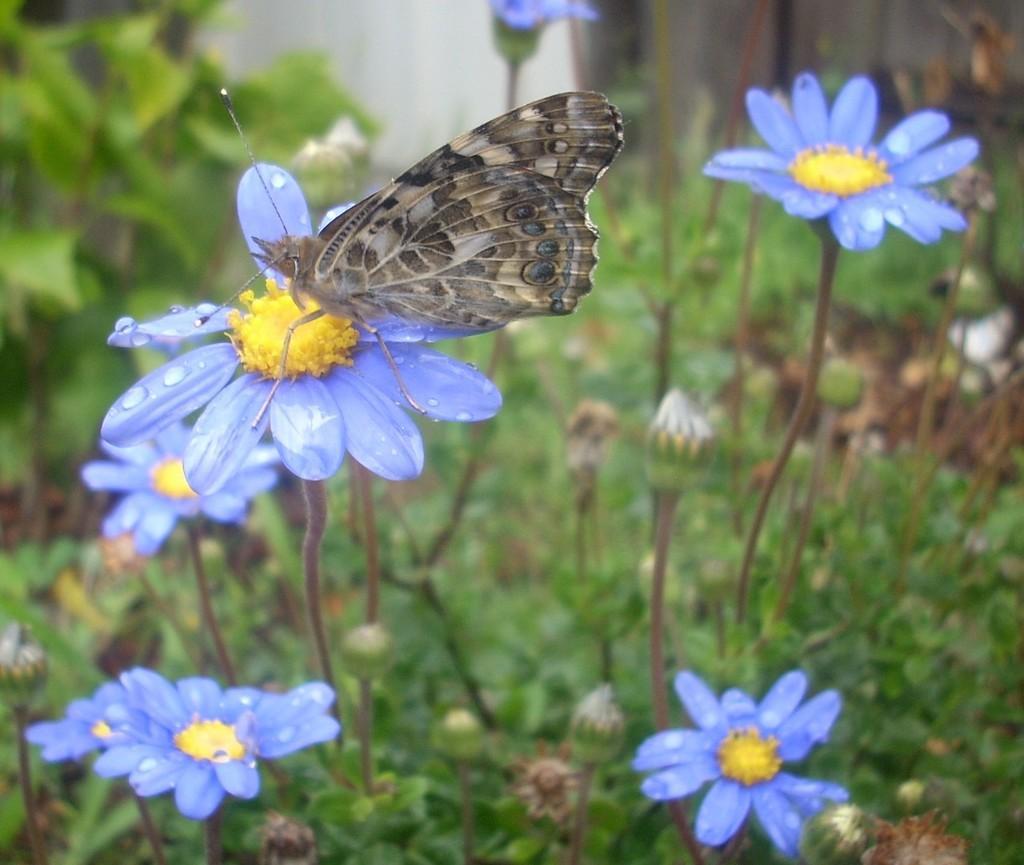Could you give a brief overview of what you see in this image? This image is taken outdoors. In the background there are a few plants. At the bottom of the image there is a ground with grass on it. In the middle of the image there are a few plants with leaves, stems and flowers. Those flowers are purple and yellow in colors. In the middle of the image there is a butterfly on the flower. 